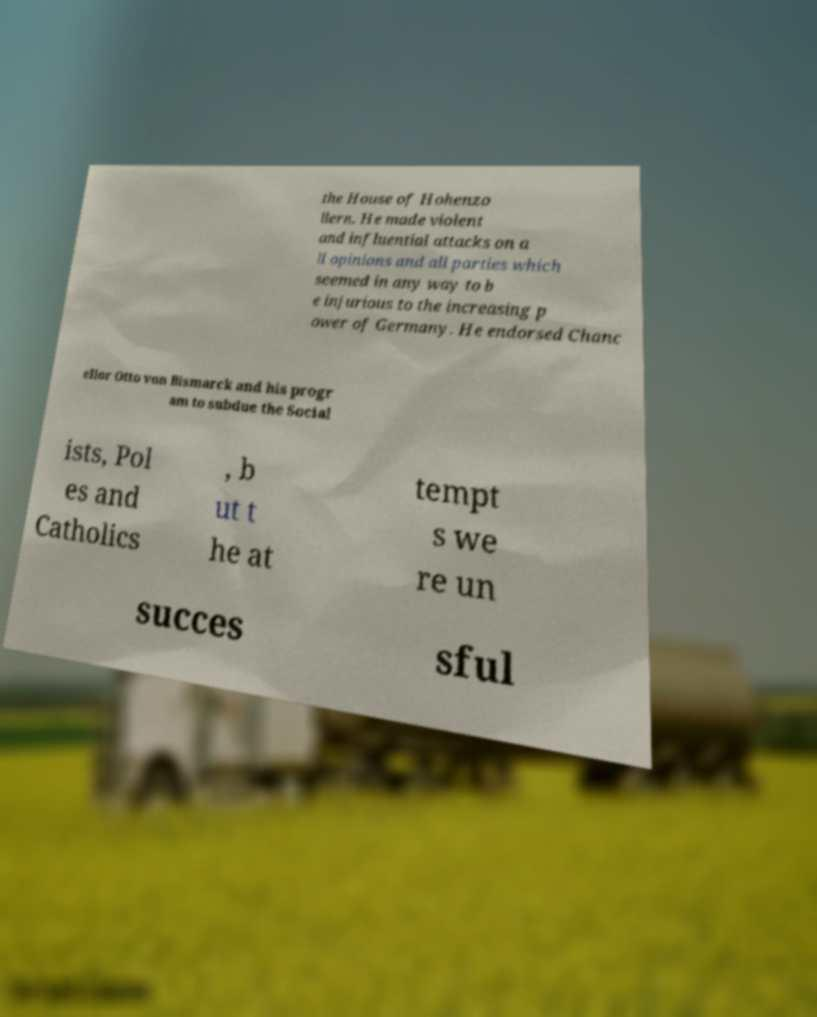Please read and relay the text visible in this image. What does it say? the House of Hohenzo llern. He made violent and influential attacks on a ll opinions and all parties which seemed in any way to b e injurious to the increasing p ower of Germany. He endorsed Chanc ellor Otto von Bismarck and his progr am to subdue the Social ists, Pol es and Catholics , b ut t he at tempt s we re un succes sful 